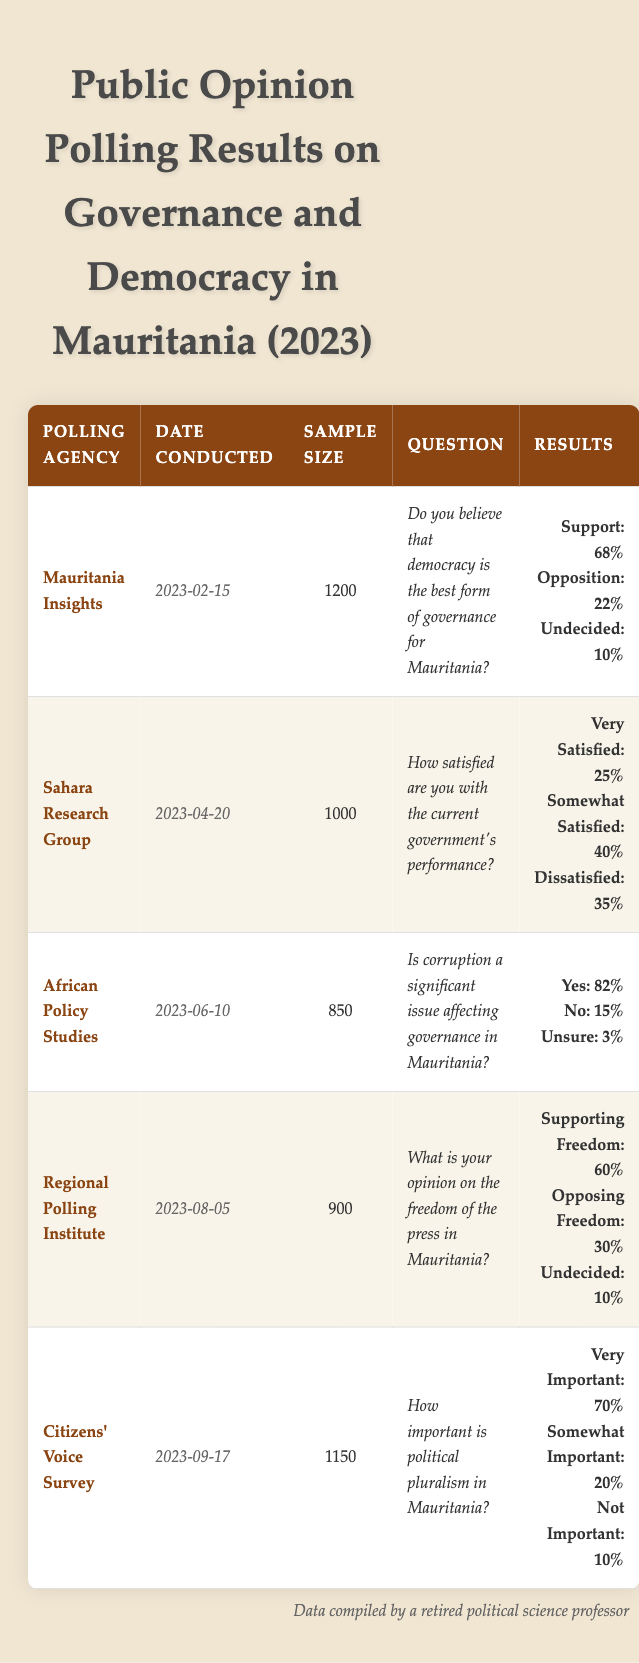What percentage of respondents believe that democracy is the best form of governance for Mauritania? According to the table, the polling agency "Mauritania Insights" conducted a survey where 68% of respondents indicated support for democracy as the best form of governance.
Answer: 68% How many respondents were very satisfied with the current government's performance? The "Sahara Research Group" survey reports that 25% of 1000 respondents were very satisfied, which calculates to 0.25 * 1000 = 250 individuals.
Answer: 250 What percentage of respondents believe corruption is a significant issue affecting governance in Mauritania? In the survey by "African Policy Studies," 82% of respondents answered yes, indicating that they believe corruption is a significant issue affecting governance.
Answer: 82% What is the total percentage of participants who support freedom of the press in Mauritania according to "Regional Polling Institute"? The survey indicates that 60% of respondents support freedom of the press, while 30% oppose it, and 10% are undecided. To find the total support percentage, we directly reference the 60% support figure provided in the table.
Answer: 60% Is the importance of political pluralism recognized by the majority of respondents in Mauritania? Based on the "Citizens' Voice Survey", 70% of respondents view political pluralism as very important and 20% see it as somewhat important. Since 70% is the majority (greater than 50%), we can affirm that the majority recognizes its importance.
Answer: Yes What is the difference in the percentage of respondents who believe democracy is the best form of governance and those who oppose it? The survey by "Mauritania Insights" states that 68% support democracy and 22% oppose it. The difference is calculated as 68 - 22 = 46.
Answer: 46 What was the sample size for the survey conducted by "African Policy Studies"? The table shows that the sample size for the "African Policy Studies" survey was 850 respondents, which is stated directly in the data.
Answer: 850 What percentage of respondents are dissatisfied with the current government's performance? According to the survey results by "Sahara Research Group," 35% of respondents indicated dissatisfaction with the current government's performance.
Answer: 35% Does the majority of Mauritanians consider political pluralism to be very important? The "Citizens' Voice Survey" indicates that 70% consider political pluralism very important, which clearly means the majority sees it as significant.
Answer: Yes 